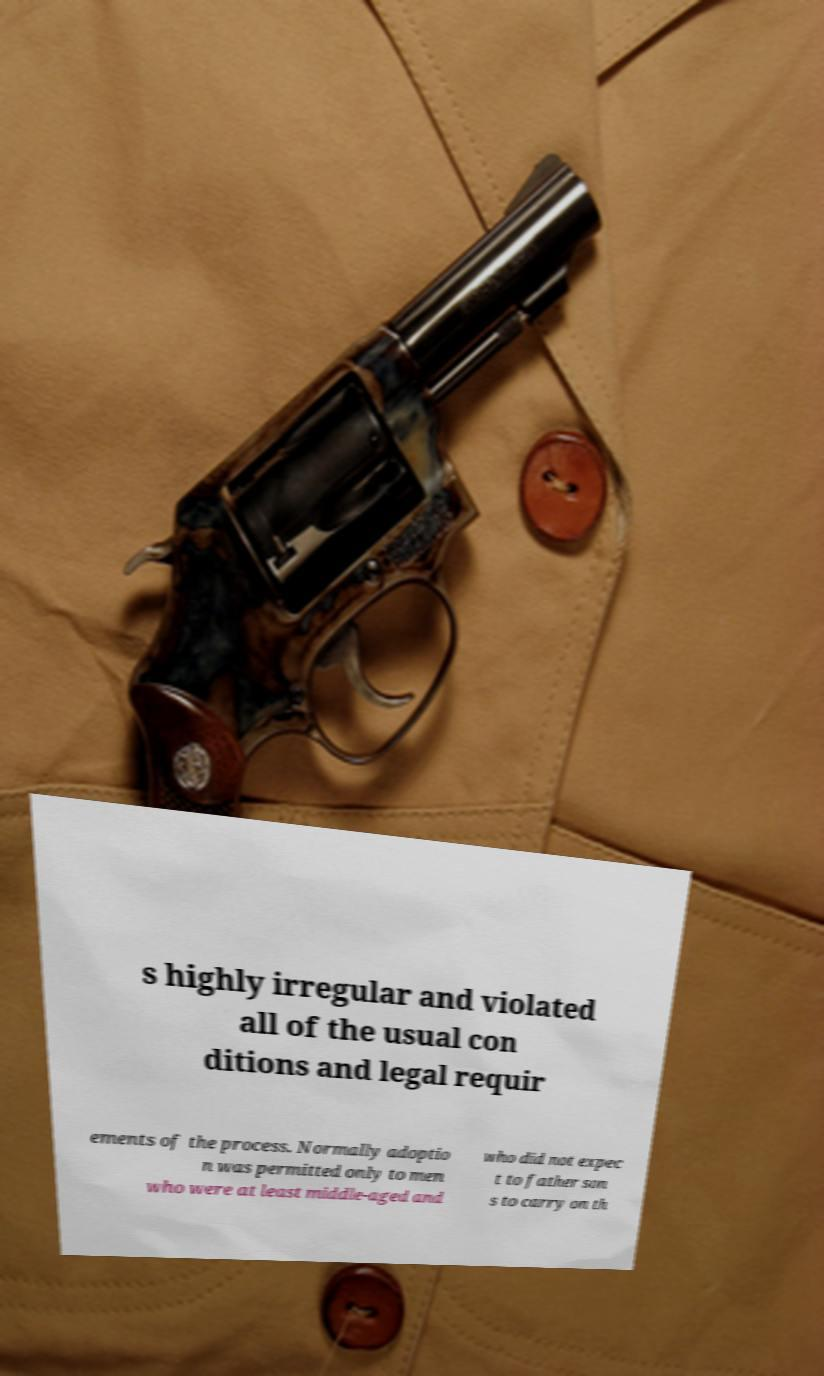I need the written content from this picture converted into text. Can you do that? s highly irregular and violated all of the usual con ditions and legal requir ements of the process. Normally adoptio n was permitted only to men who were at least middle-aged and who did not expec t to father son s to carry on th 